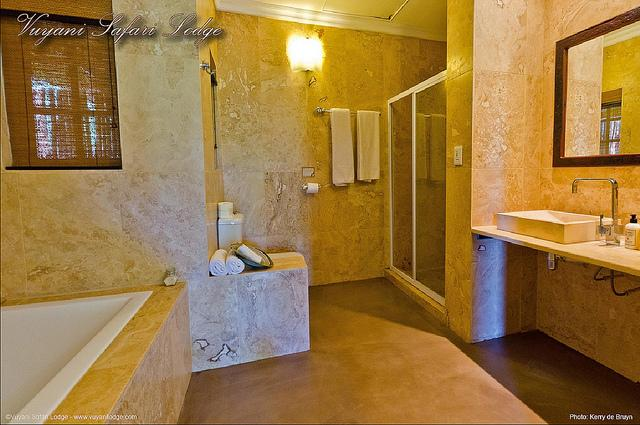What color is the lamp on the top of the wall next to the shower? Please explain your reasoning. yellow. The lamp is yellow in color. 